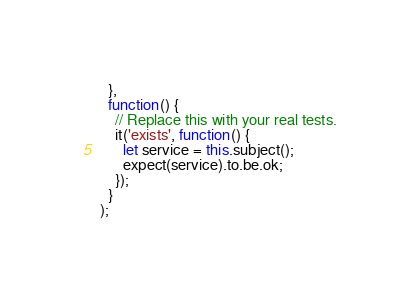Convert code to text. <code><loc_0><loc_0><loc_500><loc_500><_JavaScript_>  },
  function() {
    // Replace this with your real tests.
    it('exists', function() {
      let service = this.subject();
      expect(service).to.be.ok;
    });
  }
);
</code> 